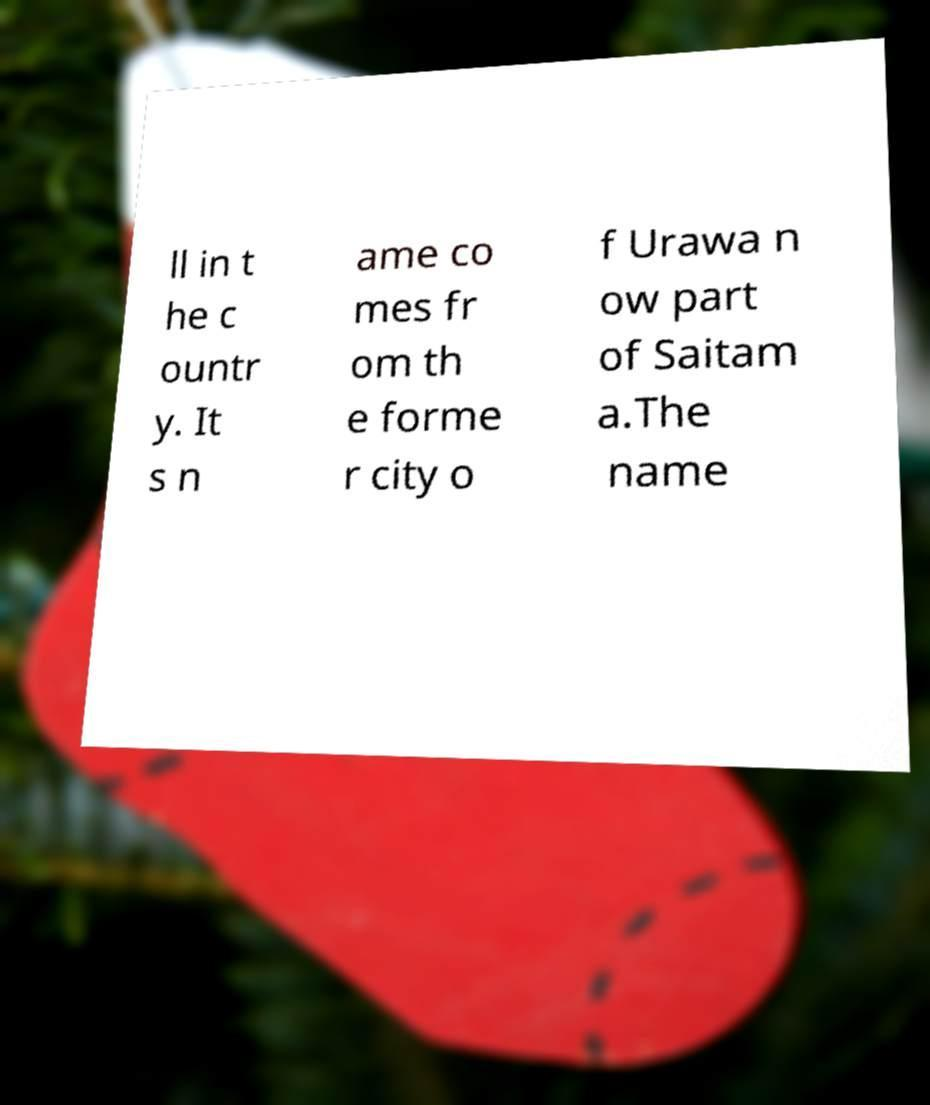Can you accurately transcribe the text from the provided image for me? ll in t he c ountr y. It s n ame co mes fr om th e forme r city o f Urawa n ow part of Saitam a.The name 